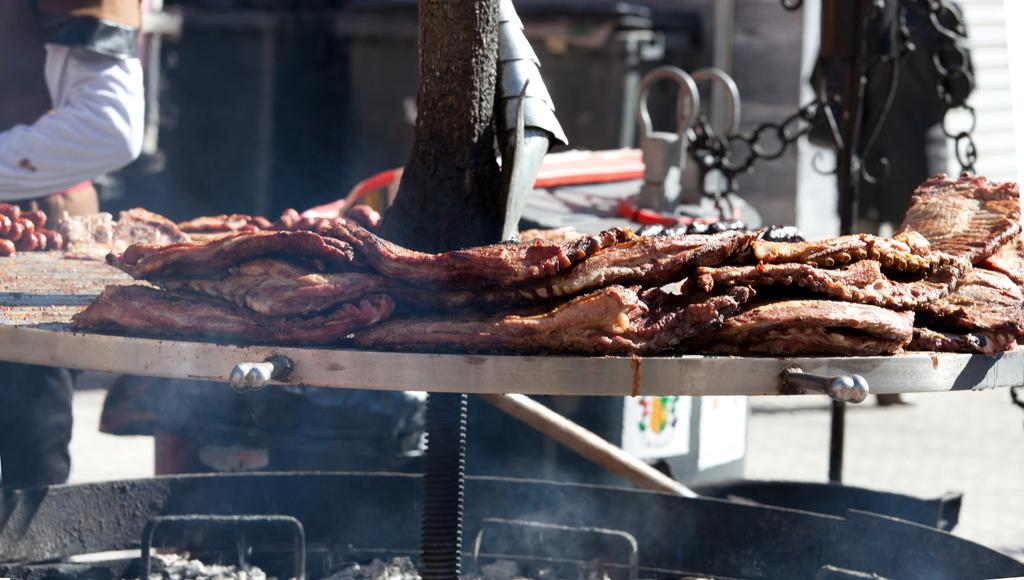What type of furniture is present in the image? There is a table in the image. What is on the table in the image? There are food items on the table. What natural element can be seen in the image? There is a tree trunk visible in the image. What else can be seen in the image besides the table and food items? There are other objects in the image. Are there any people in the image? Yes, there are people standing in the image. What type of salt can be seen on the table in the image? There is no salt visible on the table in the image. What view can be seen from the tree trunk in the image? The image does not show a view from the tree trunk, as it only shows the tree trunk itself. 